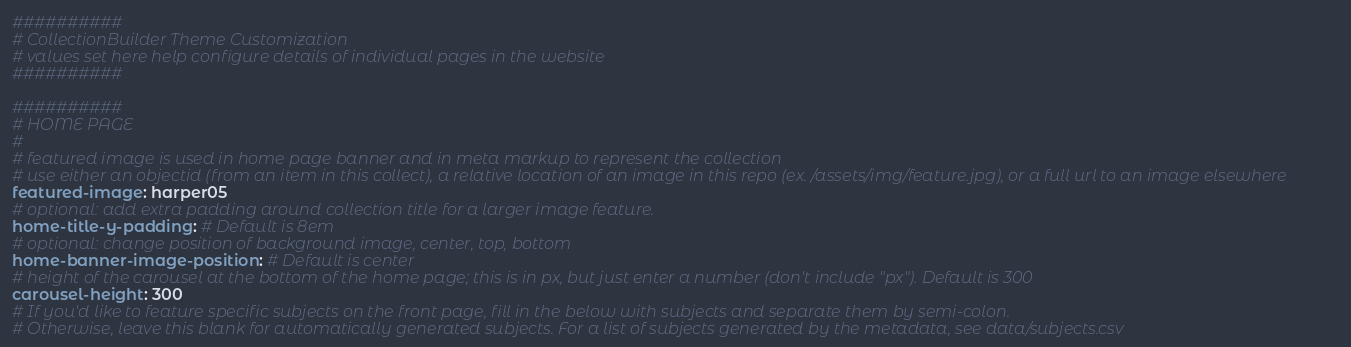Convert code to text. <code><loc_0><loc_0><loc_500><loc_500><_YAML_>##########
# CollectionBuilder Theme Customization
# values set here help configure details of individual pages in the website
##########

##########
# HOME PAGE
#
# featured image is used in home page banner and in meta markup to represent the collection
# use either an objectid (from an item in this collect), a relative location of an image in this repo (ex. /assets/img/feature.jpg), or a full url to an image elsewhere
featured-image: harper05
# optional: add extra padding around collection title for a larger image feature. 
home-title-y-padding: # Default is 8em
# optional: change position of background image, center, top, bottom
home-banner-image-position: # Default is center
# height of the carousel at the bottom of the home page; this is in px, but just enter a number (don't include "px"). Default is 300
carousel-height: 300 
# If you'd like to feature specific subjects on the front page, fill in the below with subjects and separate them by semi-colon. 
# Otherwise, leave this blank for automatically generated subjects. For a list of subjects generated by the metadata, see data/subjects.csv</code> 